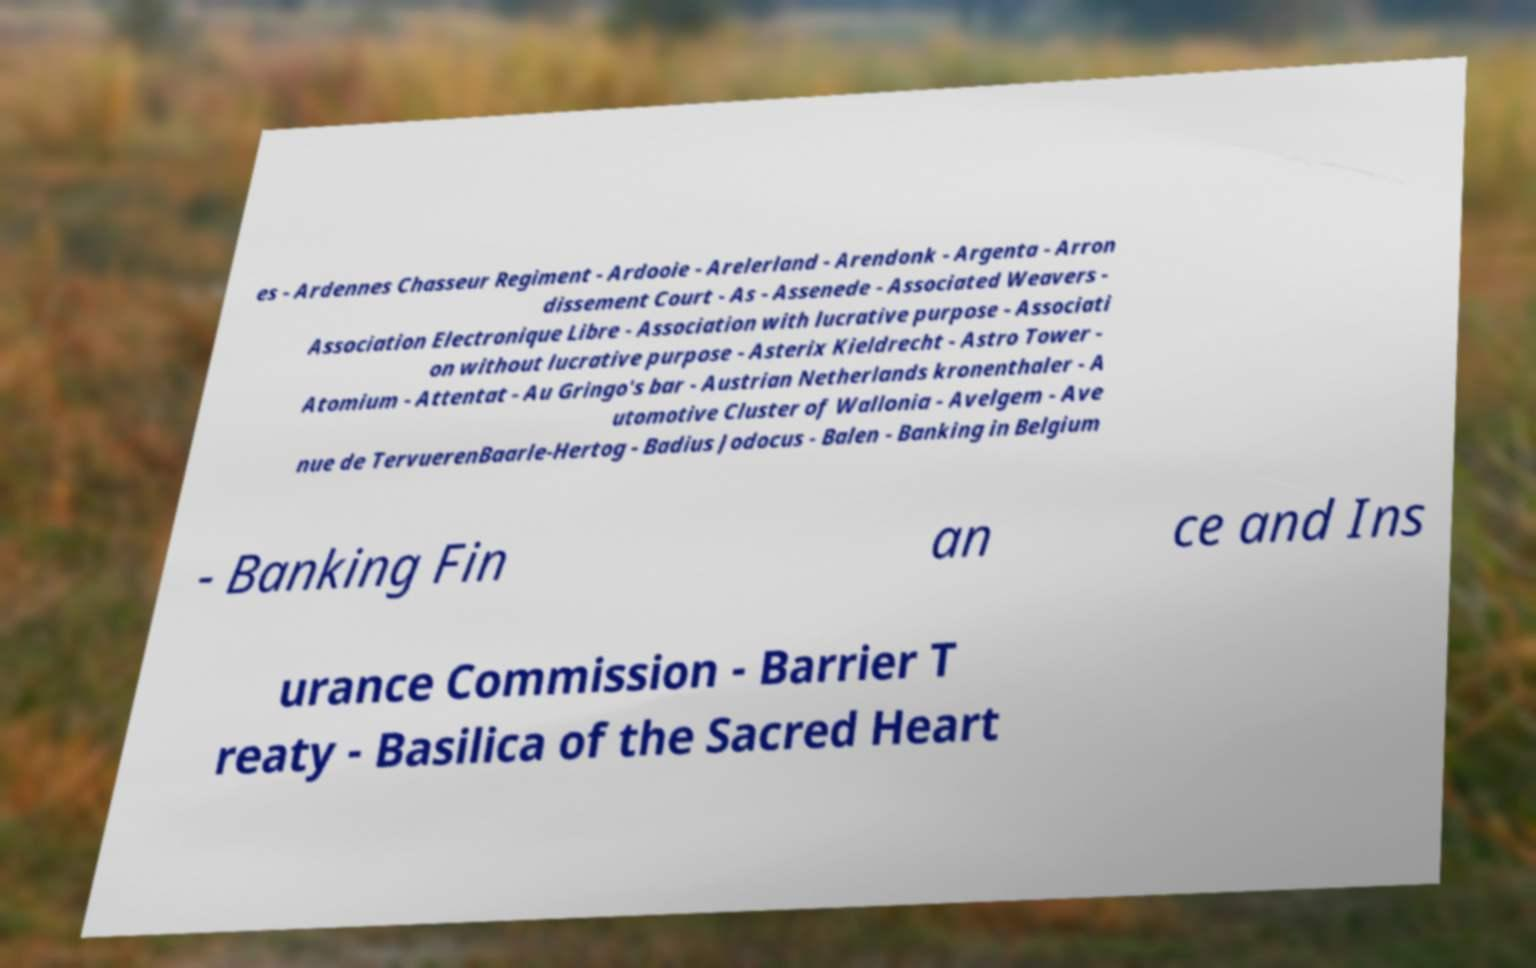Please identify and transcribe the text found in this image. es - Ardennes Chasseur Regiment - Ardooie - Arelerland - Arendonk - Argenta - Arron dissement Court - As - Assenede - Associated Weavers - Association Electronique Libre - Association with lucrative purpose - Associati on without lucrative purpose - Asterix Kieldrecht - Astro Tower - Atomium - Attentat - Au Gringo's bar - Austrian Netherlands kronenthaler - A utomotive Cluster of Wallonia - Avelgem - Ave nue de TervuerenBaarle-Hertog - Badius Jodocus - Balen - Banking in Belgium - Banking Fin an ce and Ins urance Commission - Barrier T reaty - Basilica of the Sacred Heart 